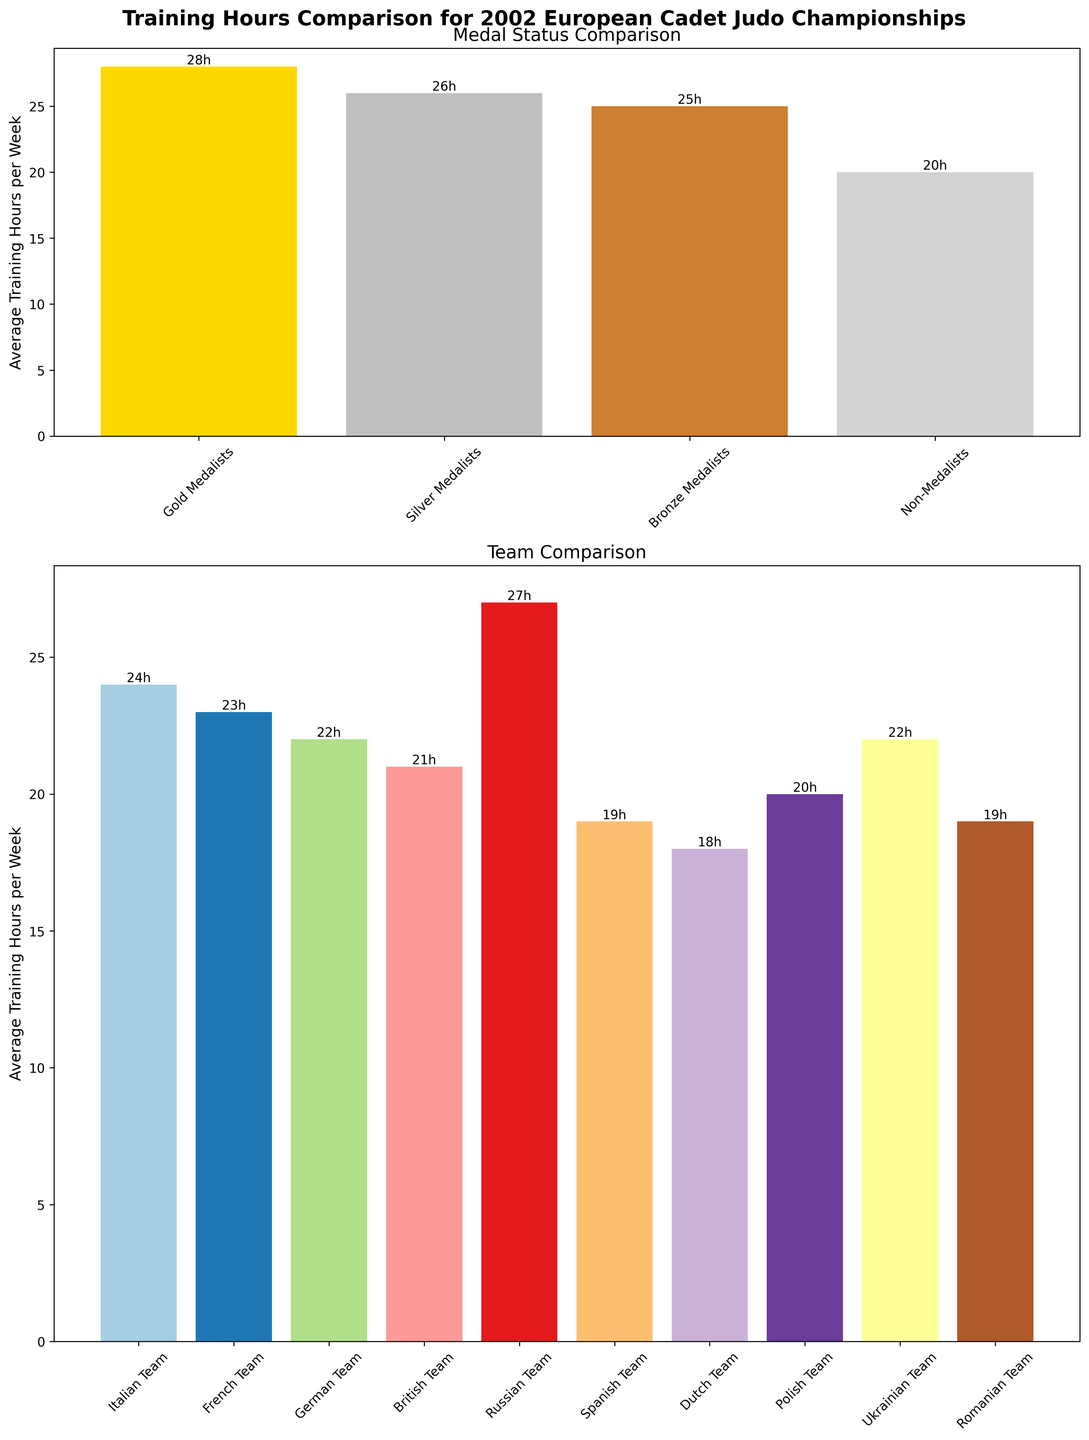Which group has the highest average training hours per week? From the figure, the bar for "Gold Medalists" is the tallest, indicating they have the highest average training hours per week.
Answer: Gold Medalists Which team trained the least on average per week? By looking at the team comparison plot, the bar for the "Dutch Team" is the shortest, indicating they trained the least on average per week.
Answer: Dutch Team What is the difference in average training hours per week between Gold Medalists and Non-Medalists? The figure shows that Gold Medalists trained 28 hours per week on average and Non-Medalists trained 20 hours per week on average. The difference is 28 - 20.
Answer: 8 hours Which medal status category trained more hours on average per week, Silver Medalists or Bronze Medalists? The figure shows that Silver Medalists trained 26 hours per week on average and Bronze Medalists trained 25 hours per week on average. Thus, Silver Medalists trained more.
Answer: Silver Medalists What is the total average training hours per week for the German, British, and Polish teams? From the team comparison plot, the average training hours per week for the German Team is 22, British Team is 21, and Polish Team is 20. The total is 22 + 21 + 20.
Answer: 63 hours Which team's average training hours are closest to the average training hours of Bronze Medalists? From the team comparison plot and the medal status plot, the Bronze Medalists averaged 25 hours per week. The Italian Team trained 24 hours, which is the closest to 25.
Answer: Italian Team What is the combined average training hours per week for all medalist categories (Gold, Silver, Bronze)? According to the figure, Gold Medalists trained 28 hours, Silver Medalists 26 hours, and Bronze Medalists 25 hours per week on average. The combined total is 28 + 26 + 25.
Answer: 79 hours Which team has a visually distinct color compared to the others? In the team comparison plot, each team is represented by a distinct color. The response will depend on the specific color schemes used but typically, any visually distinct color such as "Russian Team" usually stands out given it's near the top frequency range.
Answer: Russian Team 